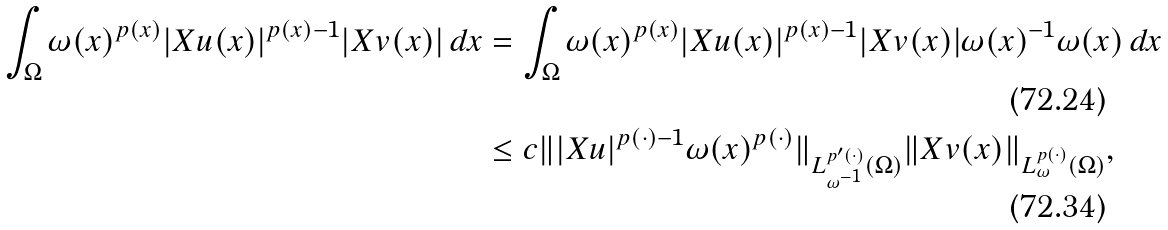Convert formula to latex. <formula><loc_0><loc_0><loc_500><loc_500>\int _ { \Omega } \omega ( x ) ^ { p ( x ) } | X u ( x ) | ^ { p ( x ) - 1 } | X v ( x ) | \, d x & = \int _ { \Omega } \omega ( x ) ^ { p ( x ) } | X u ( x ) | ^ { p ( x ) - 1 } | X v ( x ) | \omega ( x ) ^ { - 1 } \omega ( x ) \, d x \\ & \leq c \| | X u | ^ { p ( \cdot ) - 1 } \omega ( x ) ^ { p ( \cdot ) } \| _ { L ^ { p ^ { \prime } ( \cdot ) } _ { \omega ^ { - 1 } } ( \Omega ) } \| X v ( x ) \| _ { L ^ { p ( \cdot ) } _ { \omega } ( \Omega ) } ,</formula> 